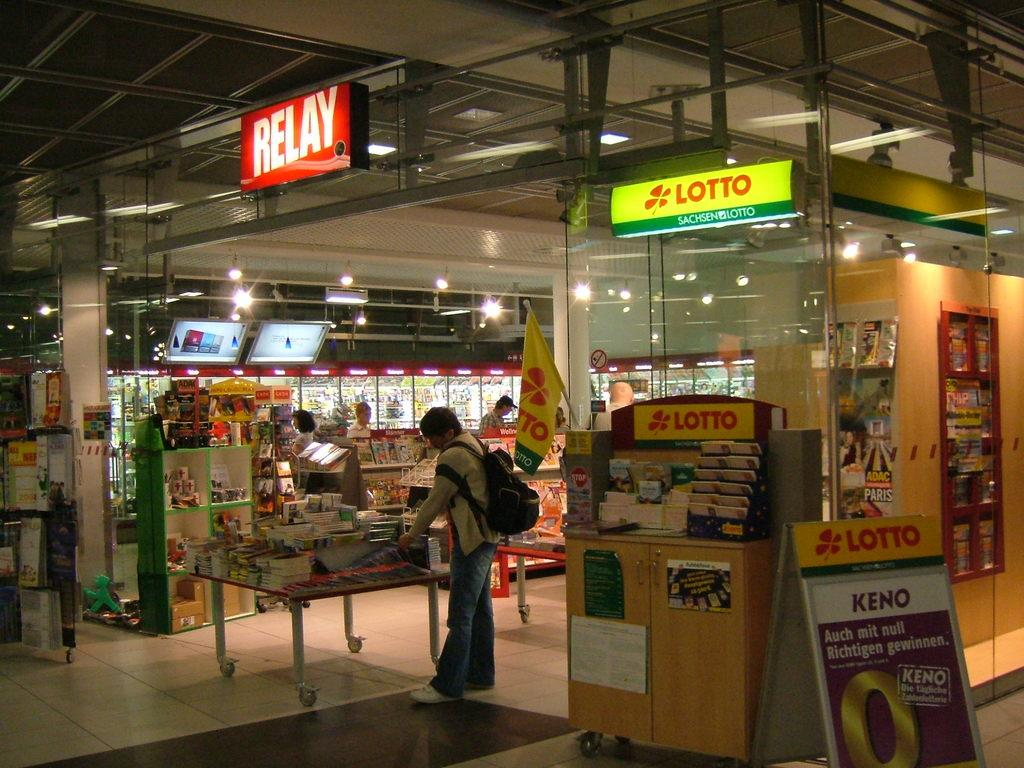<image>
Write a terse but informative summary of the picture. A mostly empty store with a Lotto machine standing right outside the front door. 